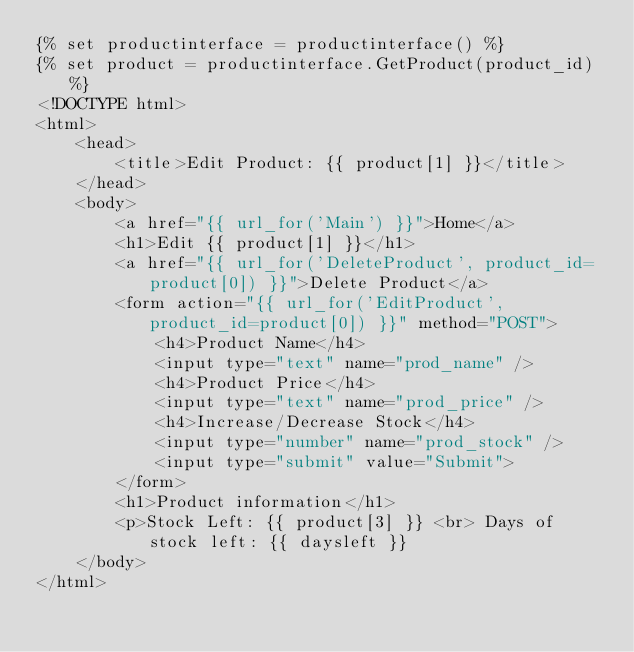Convert code to text. <code><loc_0><loc_0><loc_500><loc_500><_HTML_>{% set productinterface = productinterface() %}
{% set product = productinterface.GetProduct(product_id) %}
<!DOCTYPE html>
<html>
	<head>
		<title>Edit Product: {{ product[1] }}</title>
	</head>
	<body>
		<a href="{{ url_for('Main') }}">Home</a>
		<h1>Edit {{ product[1] }}</h1>
		<a href="{{ url_for('DeleteProduct', product_id=product[0]) }}">Delete Product</a>
		<form action="{{ url_for('EditProduct', product_id=product[0]) }}" method="POST">
			<h4>Product Name</h4>
			<input type="text" name="prod_name" />
			<h4>Product Price</h4>
			<input type="text" name="prod_price" />
			<h4>Increase/Decrease Stock</h4>
			<input type="number" name="prod_stock" />
			<input type="submit" value="Submit">
		</form>
		<h1>Product information</h1>
		<p>Stock Left: {{ product[3] }} <br> Days of stock left: {{ daysleft }}
	</body>
</html>
</code> 